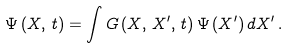Convert formula to latex. <formula><loc_0><loc_0><loc_500><loc_500>\Psi \, ( X , \, t ) = \int G \, ( X , \, X ^ { \prime } , \, t ) \, \Psi \, ( X ^ { \prime } ) \, d X ^ { \prime } \, .</formula> 